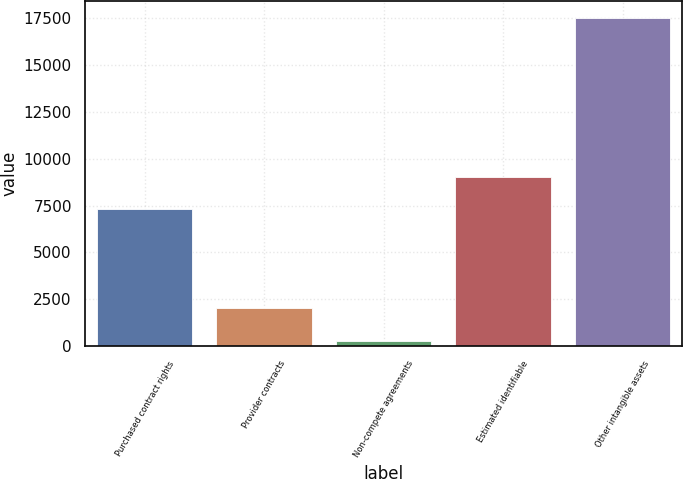<chart> <loc_0><loc_0><loc_500><loc_500><bar_chart><fcel>Purchased contract rights<fcel>Provider contracts<fcel>Non-compete agreements<fcel>Estimated identifiable<fcel>Other intangible assets<nl><fcel>7318<fcel>2021.8<fcel>300<fcel>9039.8<fcel>17518<nl></chart> 